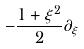<formula> <loc_0><loc_0><loc_500><loc_500>- \frac { 1 + \xi ^ { 2 } } { 2 } \partial _ { \xi }</formula> 